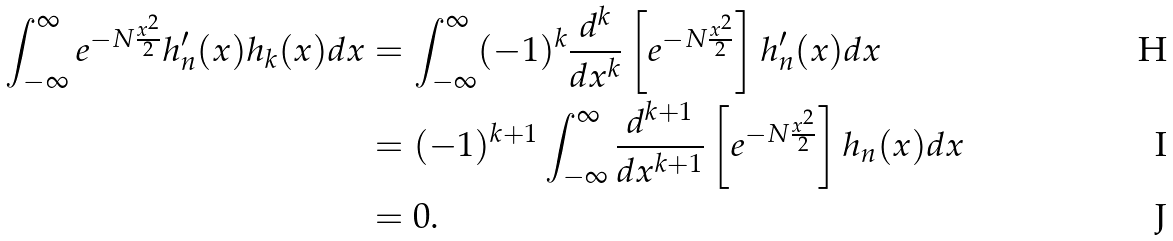<formula> <loc_0><loc_0><loc_500><loc_500>\int _ { - \infty } ^ { \infty } e ^ { - N \frac { x ^ { 2 } } { 2 } } h _ { n } ^ { \prime } ( x ) h _ { k } ( x ) d x & = \int _ { - \infty } ^ { \infty } ( - 1 ) ^ { k } \frac { d ^ { k } } { d x ^ { k } } \left [ e ^ { - N \frac { x ^ { 2 } } { 2 } } \right ] h _ { n } ^ { \prime } ( x ) d x \\ & = ( - 1 ) ^ { k + 1 } \int _ { - \infty } ^ { \infty } \frac { d ^ { k + 1 } } { d x ^ { k + 1 } } \left [ e ^ { - N \frac { x ^ { 2 } } { 2 } } \right ] h _ { n } ( x ) d x \\ & = 0 .</formula> 